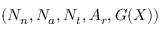<formula> <loc_0><loc_0><loc_500><loc_500>( N _ { n } , N _ { a } , N _ { t } , A _ { r } , G ( X ) )</formula> 